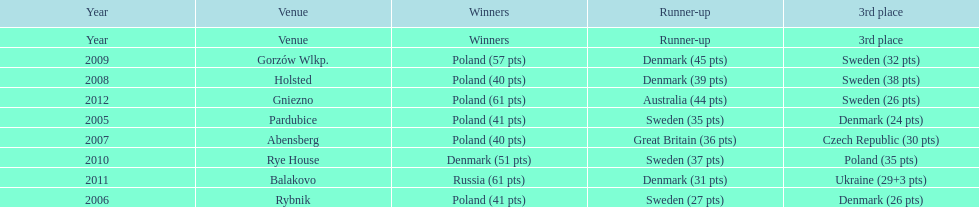Help me parse the entirety of this table. {'header': ['Year', 'Venue', 'Winners', 'Runner-up', '3rd place'], 'rows': [['Year', 'Venue', 'Winners', 'Runner-up', '3rd place'], ['2009', 'Gorzów Wlkp.', 'Poland (57 pts)', 'Denmark (45 pts)', 'Sweden (32 pts)'], ['2008', 'Holsted', 'Poland (40 pts)', 'Denmark (39 pts)', 'Sweden (38 pts)'], ['2012', 'Gniezno', 'Poland (61 pts)', 'Australia (44 pts)', 'Sweden (26 pts)'], ['2005', 'Pardubice', 'Poland (41 pts)', 'Sweden (35 pts)', 'Denmark (24 pts)'], ['2007', 'Abensberg', 'Poland (40 pts)', 'Great Britain (36 pts)', 'Czech Republic (30 pts)'], ['2010', 'Rye House', 'Denmark (51 pts)', 'Sweden (37 pts)', 'Poland (35 pts)'], ['2011', 'Balakovo', 'Russia (61 pts)', 'Denmark (31 pts)', 'Ukraine (29+3 pts)'], ['2006', 'Rybnik', 'Poland (41 pts)', 'Sweden (27 pts)', 'Denmark (26 pts)']]} What is the total number of points earned in the years 2009? 134. 